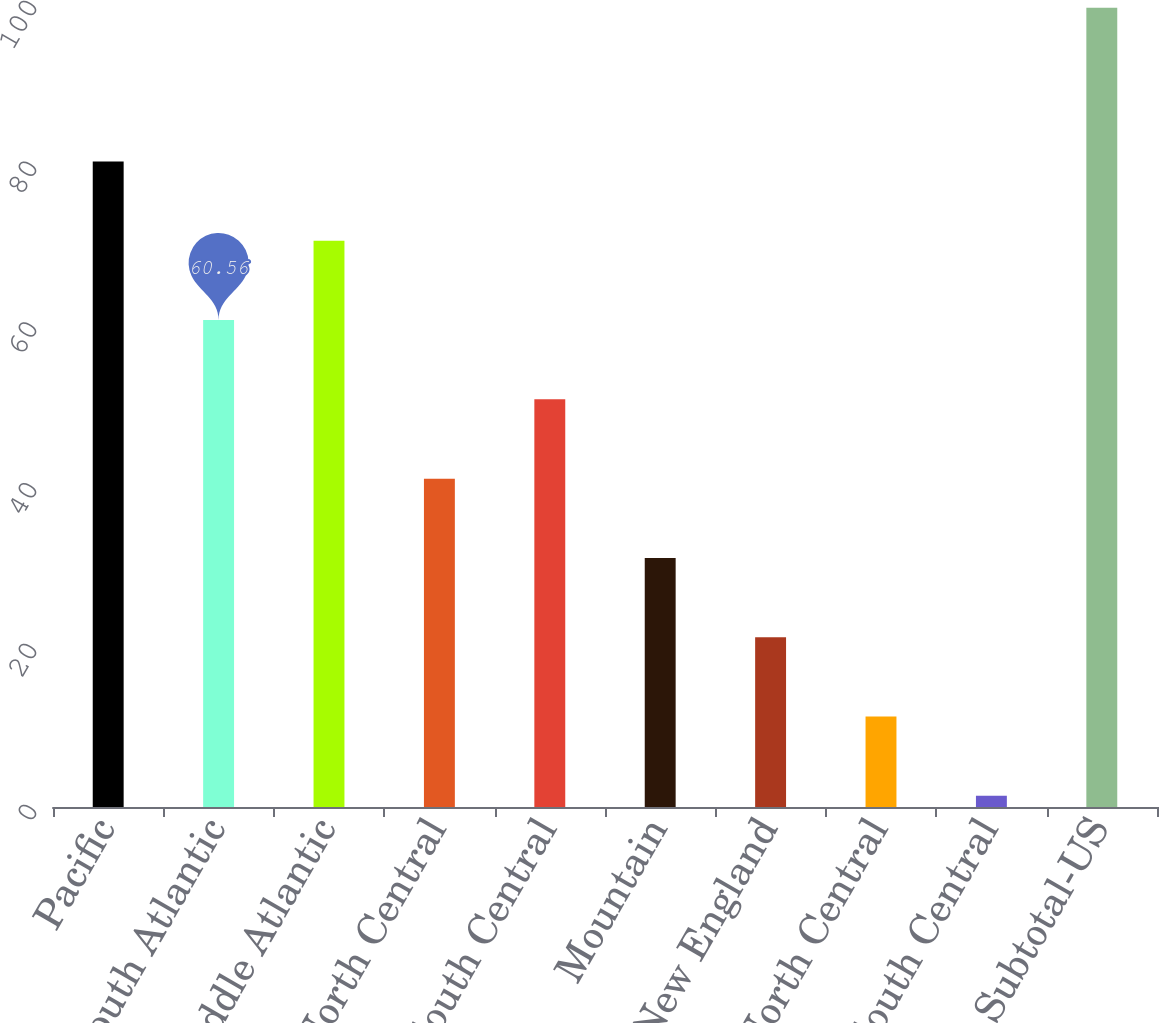<chart> <loc_0><loc_0><loc_500><loc_500><bar_chart><fcel>Pacific<fcel>South Atlantic<fcel>Middle Atlantic<fcel>East North Central<fcel>West South Central<fcel>Mountain<fcel>New England<fcel>West North Central<fcel>East South Central<fcel>Subtotal-US<nl><fcel>80.28<fcel>60.56<fcel>70.42<fcel>40.84<fcel>50.7<fcel>30.98<fcel>21.12<fcel>11.26<fcel>1.4<fcel>99.4<nl></chart> 